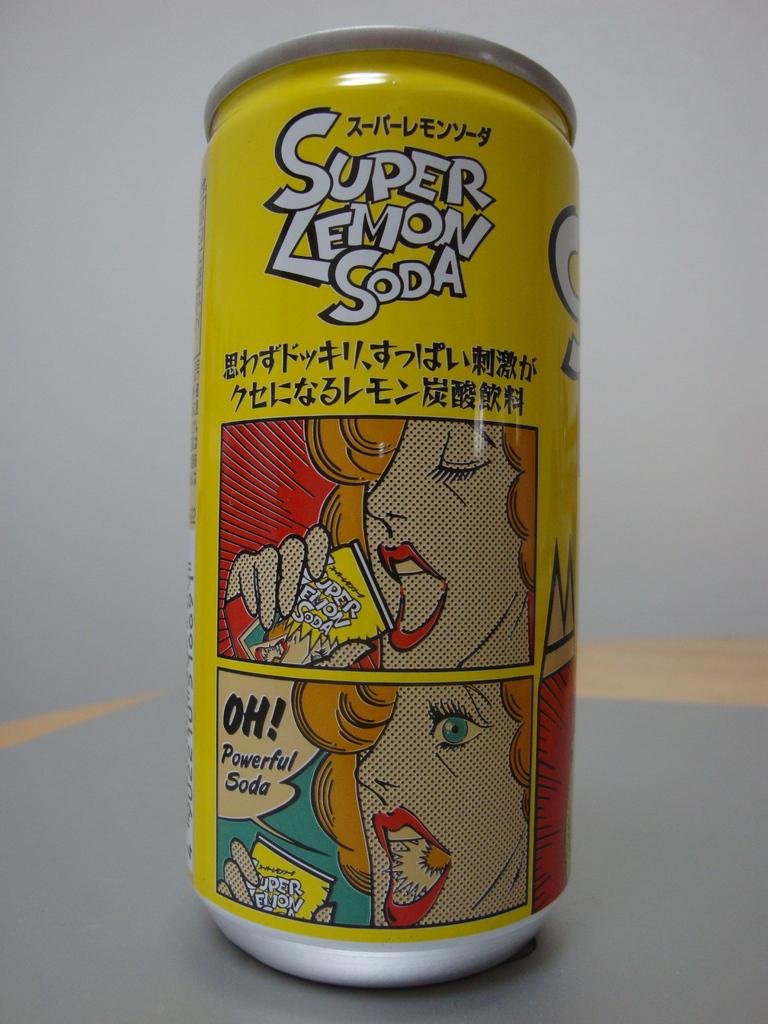What does the botle contain?
Make the answer very short. Super lemon soda. 